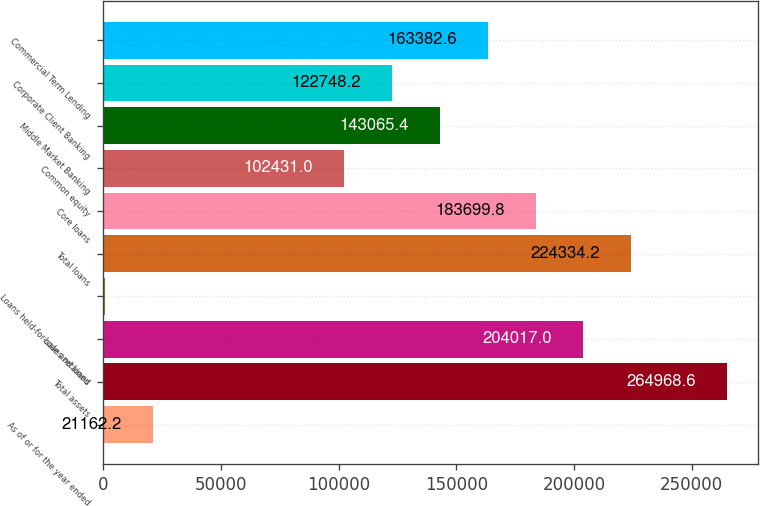Convert chart. <chart><loc_0><loc_0><loc_500><loc_500><bar_chart><fcel>As of or for the year ended<fcel>Total assets<fcel>Loans retained<fcel>Loans held-for-sale and loans<fcel>Total loans<fcel>Core loans<fcel>Common equity<fcel>Middle Market Banking<fcel>Corporate Client Banking<fcel>Commercial Term Lending<nl><fcel>21162.2<fcel>264969<fcel>204017<fcel>845<fcel>224334<fcel>183700<fcel>102431<fcel>143065<fcel>122748<fcel>163383<nl></chart> 